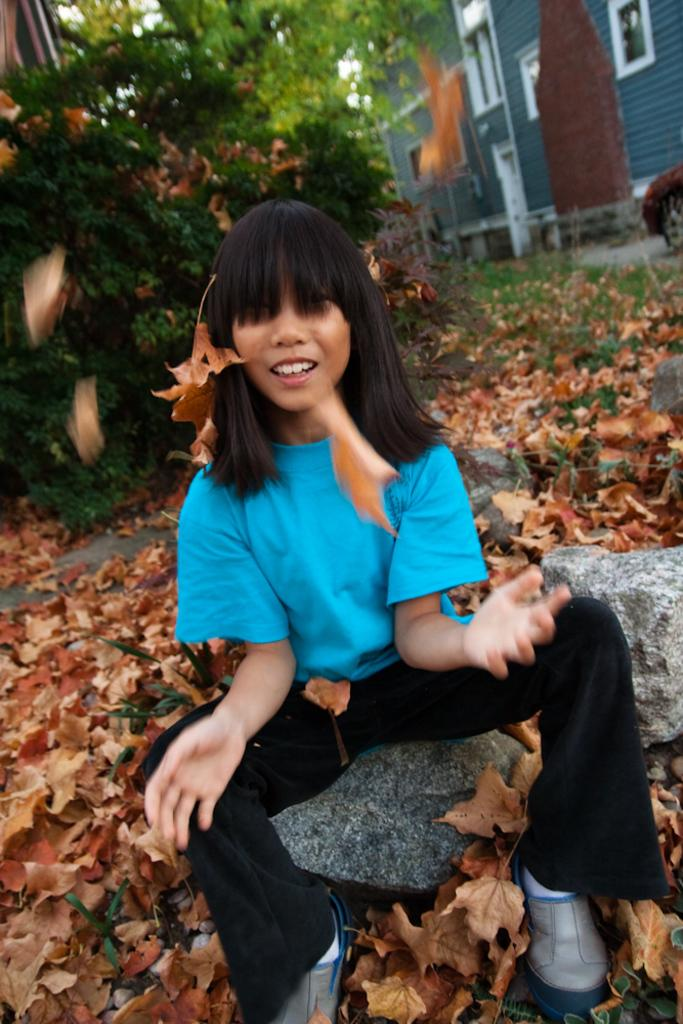What is the girl in the image doing? The girl is sitting on a rock in the image. What type of vegetation can be seen in the image? Leaves are visible in the image. What can be seen in the background of the image? There is a building and windows in the background of the image. What type of flight is the girl taking in the image? There is no flight present in the image; the girl is sitting on a rock. What type of leaf is the girl holding in the image? There is no leaf being held by the girl in the image; only leaves can be seen in the background. 